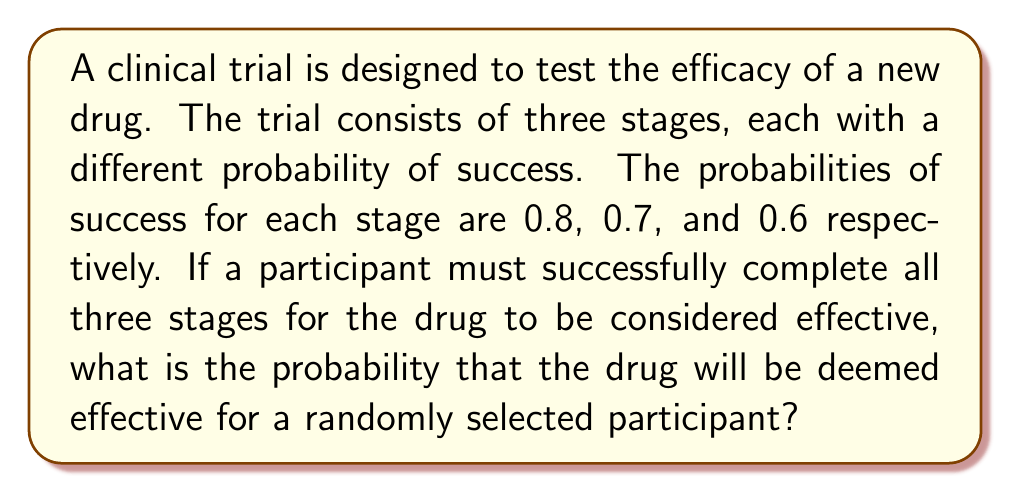Give your solution to this math problem. To solve this problem, we need to apply the multiplication rule of probability for independent events. Let's break it down step-by-step:

1) Let's define our events:
   $A$: Success in stage 1
   $B$: Success in stage 2
   $C$: Success in stage 3

2) We're given the following probabilities:
   $P(A) = 0.8$
   $P(B) = 0.7$
   $P(C) = 0.6$

3) For the drug to be deemed effective, a participant must succeed in all three stages. This means we need to calculate $P(A \cap B \cap C)$.

4) Since the stages are independent (the success in one stage doesn't affect the probability of success in another), we can use the multiplication rule:

   $P(A \cap B \cap C) = P(A) \cdot P(B) \cdot P(C)$

5) Now, let's substitute the values:

   $P(A \cap B \cap C) = 0.8 \cdot 0.7 \cdot 0.6$

6) Calculate:
   $P(A \cap B \cap C) = 0.336$

Therefore, the probability that the drug will be deemed effective for a randomly selected participant is 0.336 or 33.6%.
Answer: 0.336 